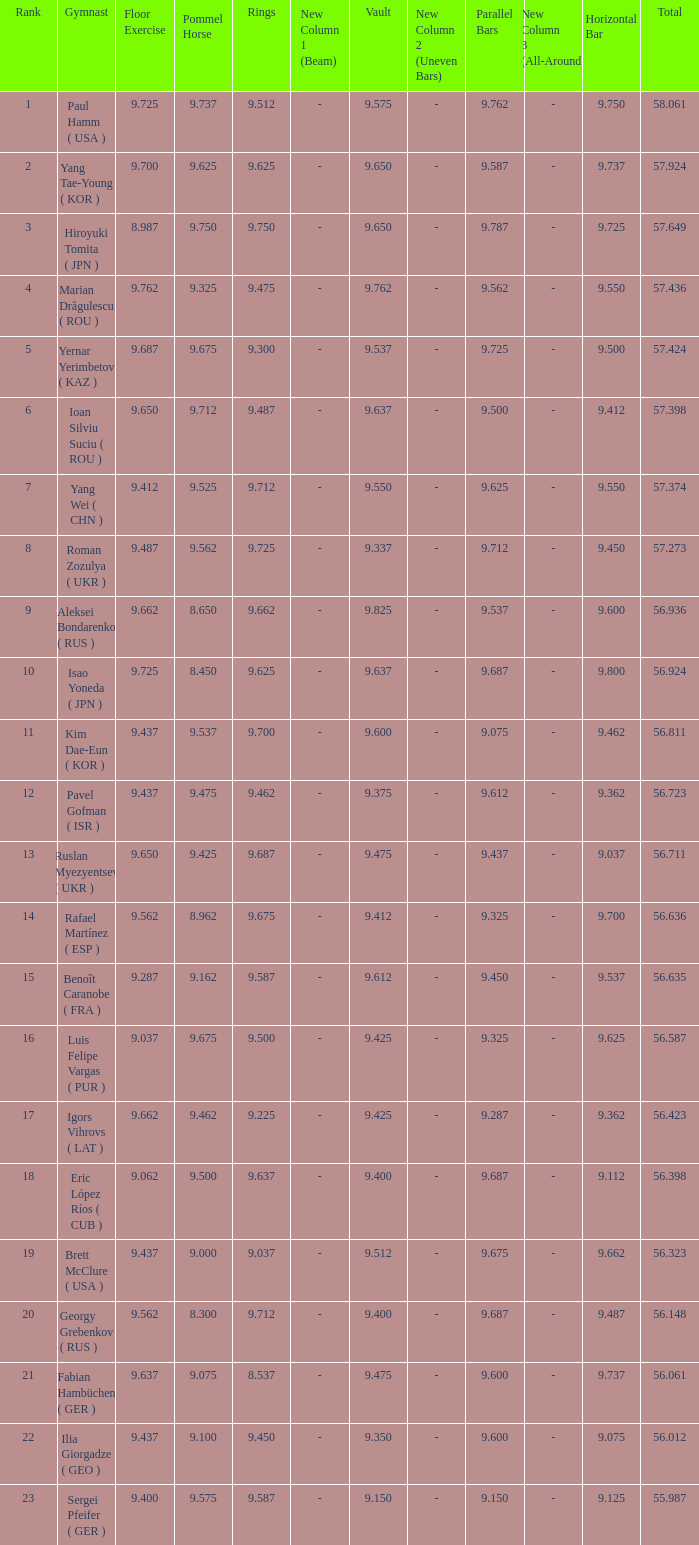What is the vault score for the total of 56.635? 9.612. 